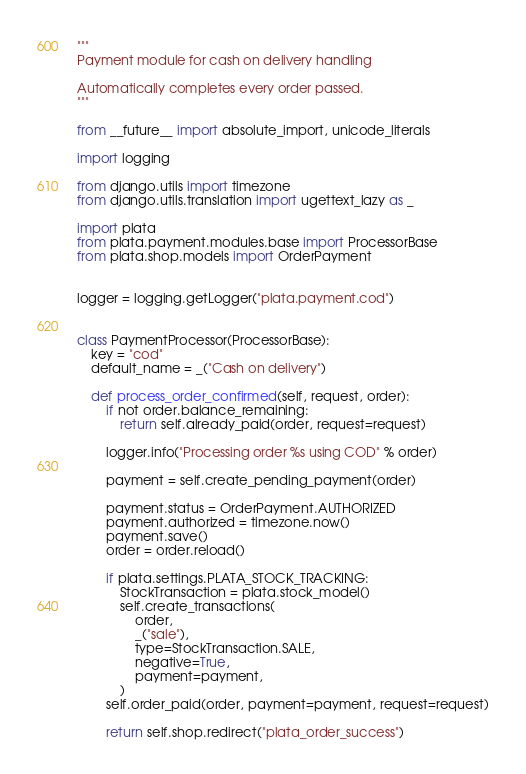Convert code to text. <code><loc_0><loc_0><loc_500><loc_500><_Python_>"""
Payment module for cash on delivery handling

Automatically completes every order passed.
"""

from __future__ import absolute_import, unicode_literals

import logging

from django.utils import timezone
from django.utils.translation import ugettext_lazy as _

import plata
from plata.payment.modules.base import ProcessorBase
from plata.shop.models import OrderPayment


logger = logging.getLogger("plata.payment.cod")


class PaymentProcessor(ProcessorBase):
    key = "cod"
    default_name = _("Cash on delivery")

    def process_order_confirmed(self, request, order):
        if not order.balance_remaining:
            return self.already_paid(order, request=request)

        logger.info("Processing order %s using COD" % order)

        payment = self.create_pending_payment(order)

        payment.status = OrderPayment.AUTHORIZED
        payment.authorized = timezone.now()
        payment.save()
        order = order.reload()

        if plata.settings.PLATA_STOCK_TRACKING:
            StockTransaction = plata.stock_model()
            self.create_transactions(
                order,
                _("sale"),
                type=StockTransaction.SALE,
                negative=True,
                payment=payment,
            )
        self.order_paid(order, payment=payment, request=request)

        return self.shop.redirect("plata_order_success")
</code> 